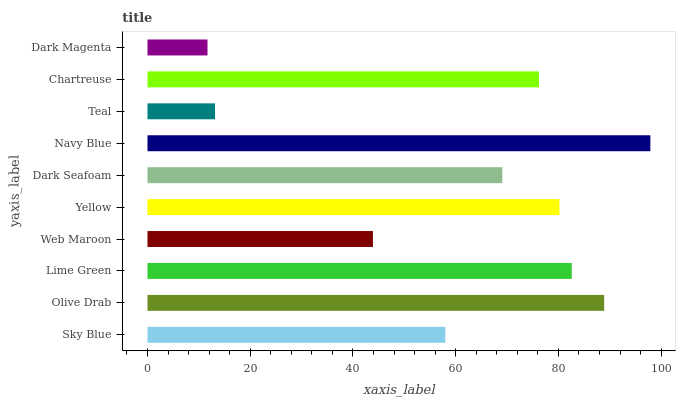Is Dark Magenta the minimum?
Answer yes or no. Yes. Is Navy Blue the maximum?
Answer yes or no. Yes. Is Olive Drab the minimum?
Answer yes or no. No. Is Olive Drab the maximum?
Answer yes or no. No. Is Olive Drab greater than Sky Blue?
Answer yes or no. Yes. Is Sky Blue less than Olive Drab?
Answer yes or no. Yes. Is Sky Blue greater than Olive Drab?
Answer yes or no. No. Is Olive Drab less than Sky Blue?
Answer yes or no. No. Is Chartreuse the high median?
Answer yes or no. Yes. Is Dark Seafoam the low median?
Answer yes or no. Yes. Is Teal the high median?
Answer yes or no. No. Is Navy Blue the low median?
Answer yes or no. No. 